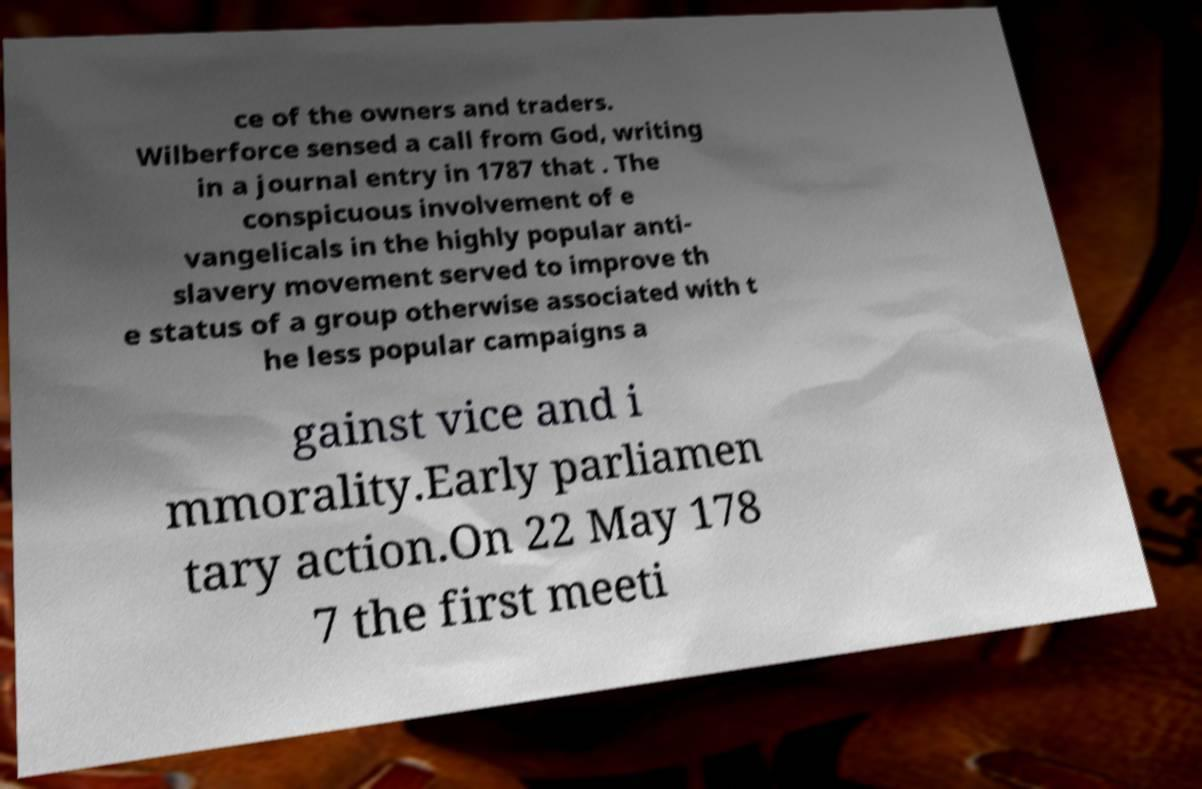For documentation purposes, I need the text within this image transcribed. Could you provide that? ce of the owners and traders. Wilberforce sensed a call from God, writing in a journal entry in 1787 that . The conspicuous involvement of e vangelicals in the highly popular anti- slavery movement served to improve th e status of a group otherwise associated with t he less popular campaigns a gainst vice and i mmorality.Early parliamen tary action.On 22 May 178 7 the first meeti 